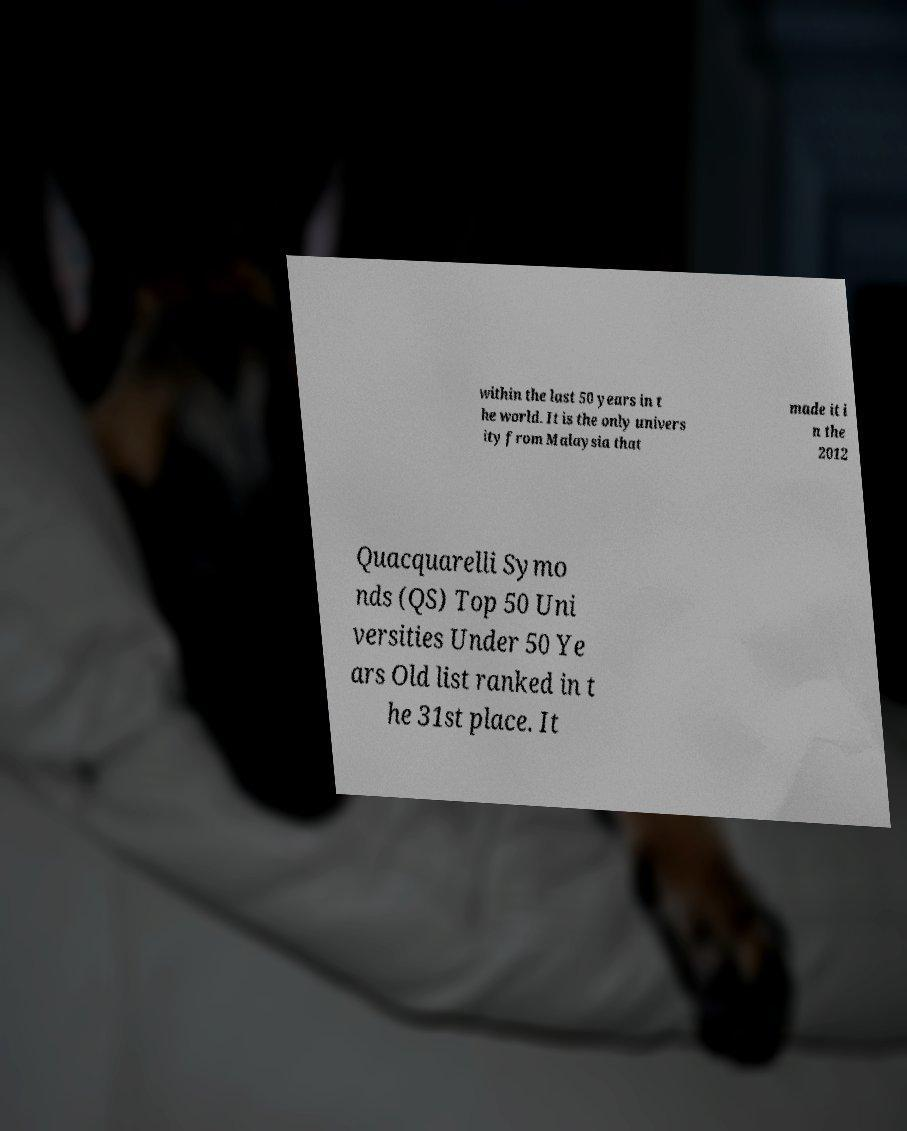There's text embedded in this image that I need extracted. Can you transcribe it verbatim? within the last 50 years in t he world. It is the only univers ity from Malaysia that made it i n the 2012 Quacquarelli Symo nds (QS) Top 50 Uni versities Under 50 Ye ars Old list ranked in t he 31st place. It 